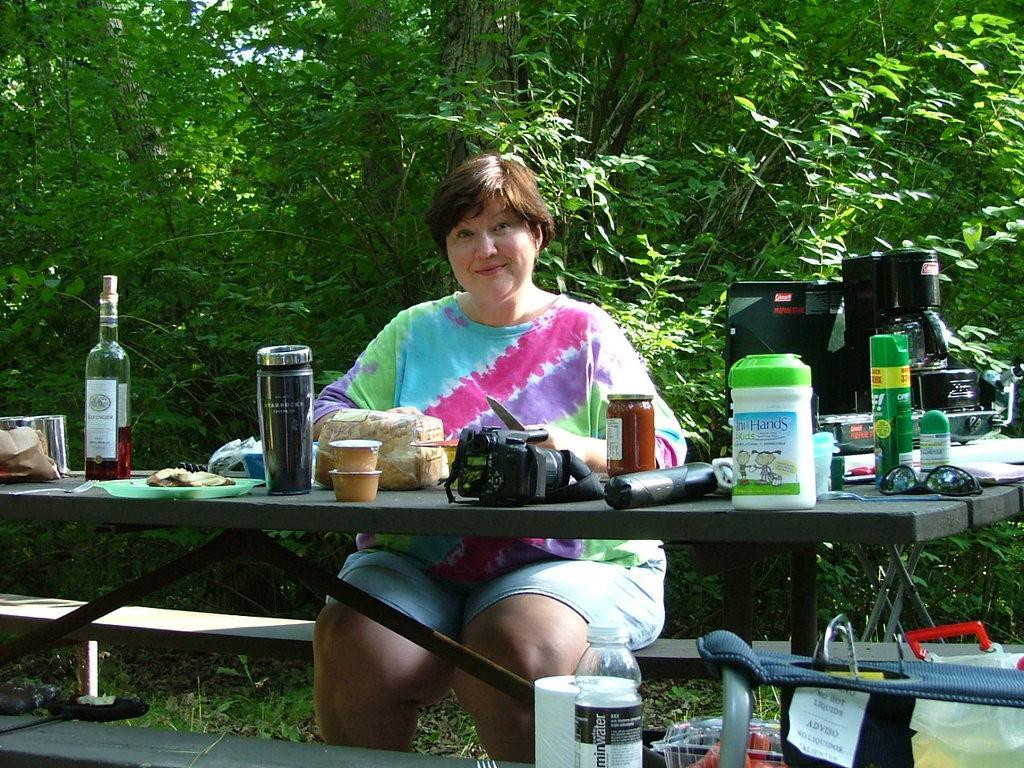How would you summarize this image in a sentence or two? In this picture a lady is sitting on the table where there are many objects placed in front of them which include a glass wine bottle, few food items , a bag , camera and a tea kettle. In the background we observe small trees. To the right side of the image there are also few objects placed on the table like tissue roll, water bottle and a bag. 